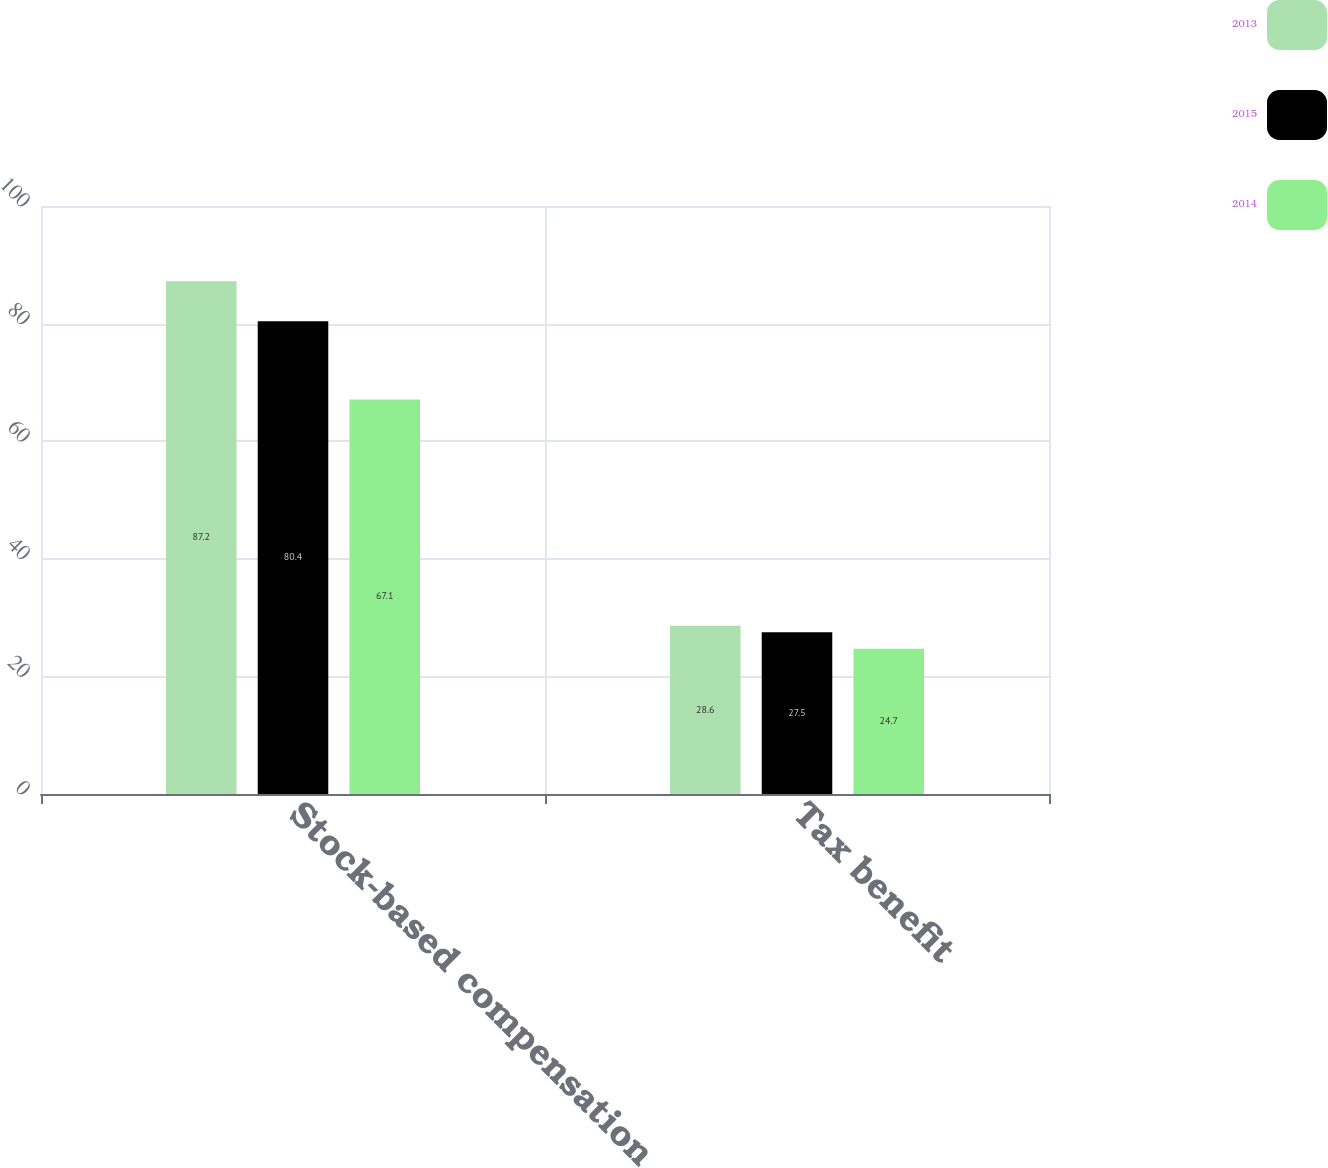Convert chart. <chart><loc_0><loc_0><loc_500><loc_500><stacked_bar_chart><ecel><fcel>Stock-based compensation<fcel>Tax benefit<nl><fcel>2013<fcel>87.2<fcel>28.6<nl><fcel>2015<fcel>80.4<fcel>27.5<nl><fcel>2014<fcel>67.1<fcel>24.7<nl></chart> 